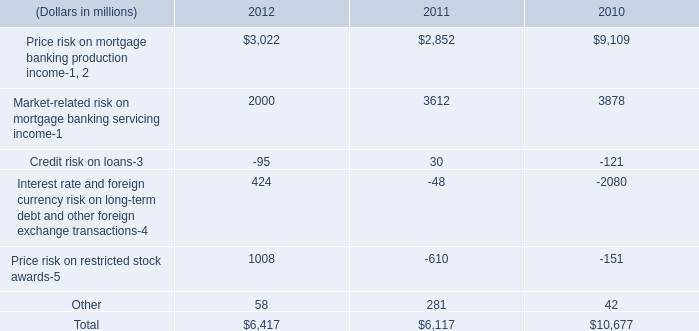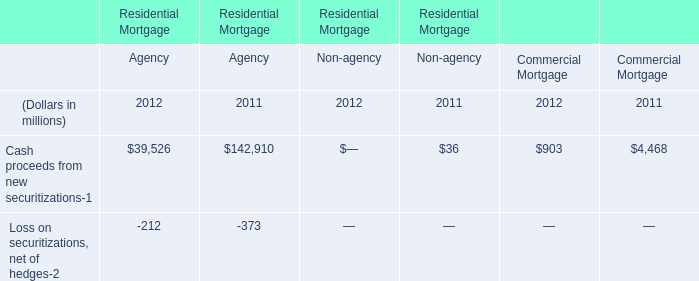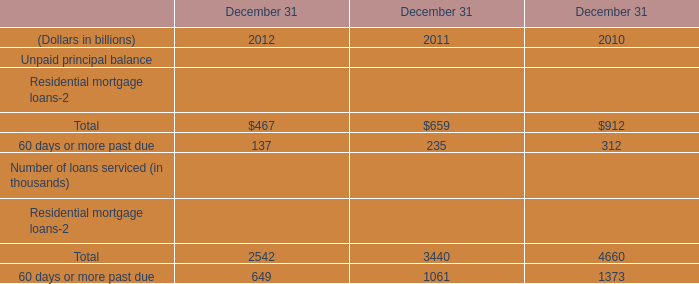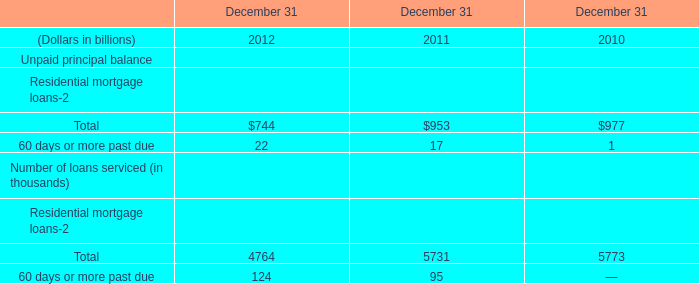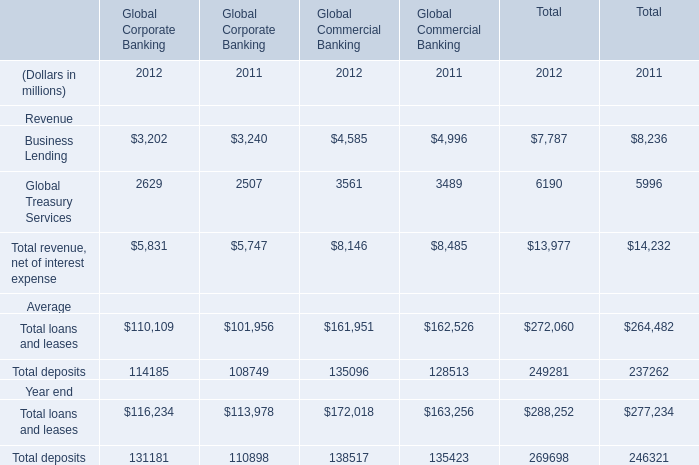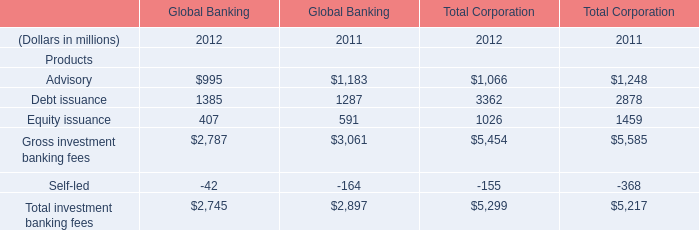What's the increasing rate of Global Treasury Services of Global Commercial Banking in 2012? (in %) 
Computations: ((3561 - 3489) / 3489)
Answer: 0.02064. 